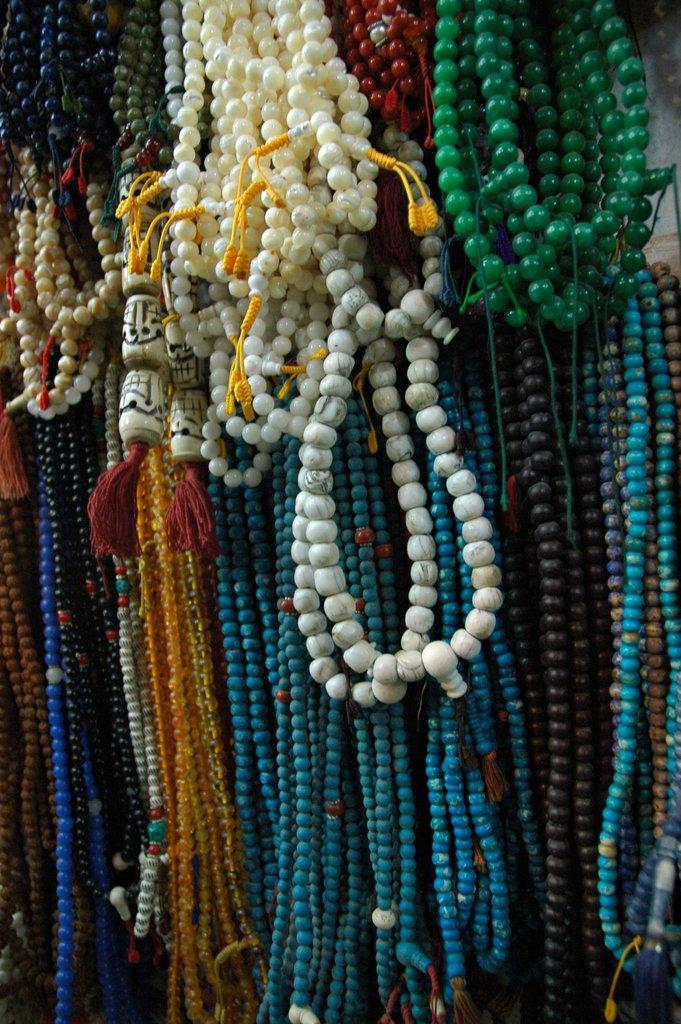What type of jewelry is present in the image? There are colorful bead necklaces in the image. Can you describe the appearance of the necklaces? The necklaces are colorful and made of beads. What might someone use these necklaces for? These necklaces could be used for decoration or as a fashion accessory. Where is the sink located in the image? There is no sink present in the image; it only features colorful bead necklaces. What type of sea creature can be seen swimming near the necklaces? There are no sea creatures present in the image; it only features colorful bead necklaces. 